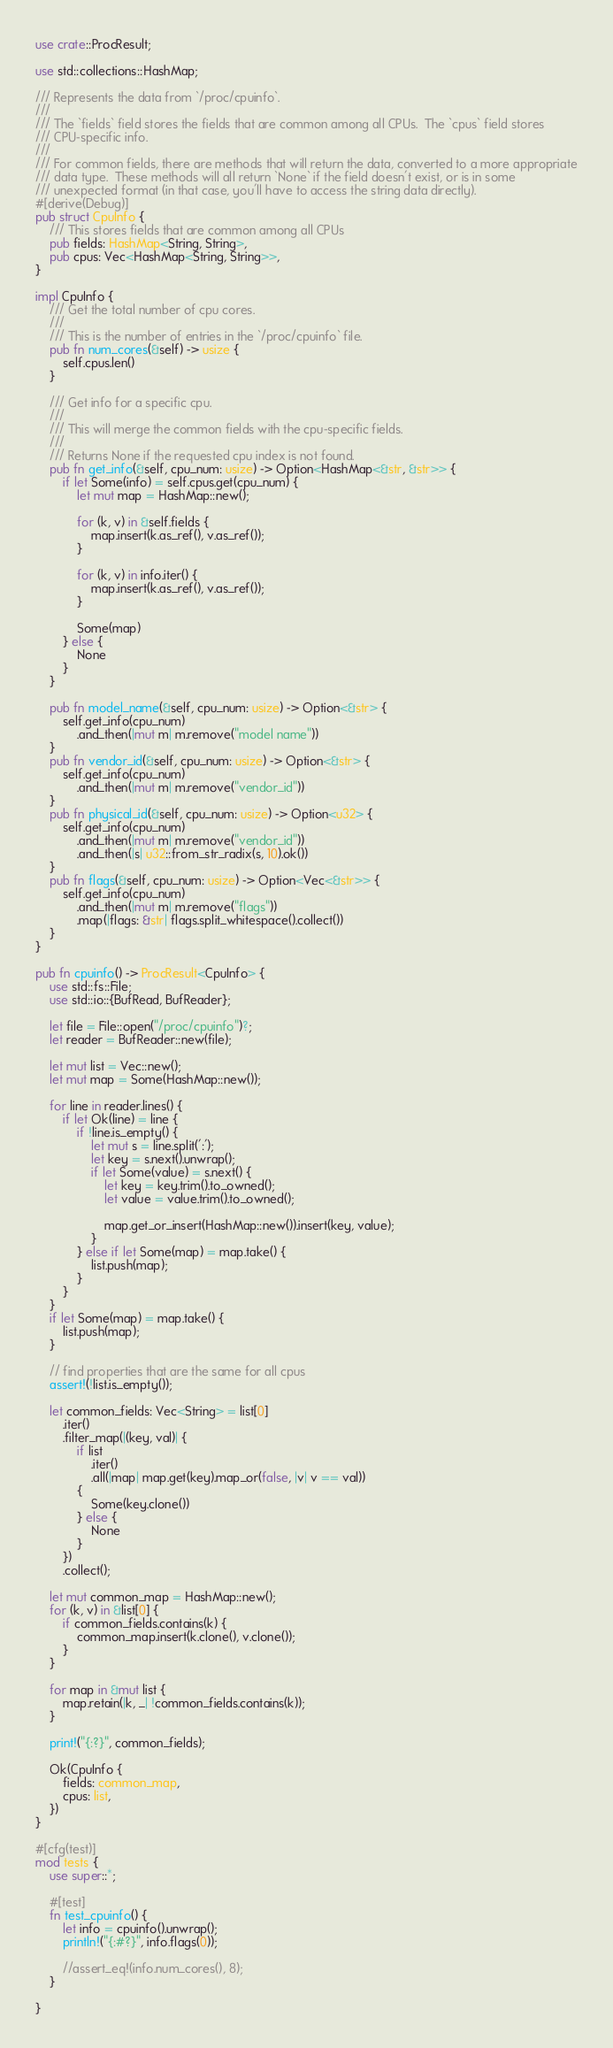Convert code to text. <code><loc_0><loc_0><loc_500><loc_500><_Rust_>use crate::ProcResult;

use std::collections::HashMap;

/// Represents the data from `/proc/cpuinfo`.
///
/// The `fields` field stores the fields that are common among all CPUs.  The `cpus` field stores
/// CPU-specific info.
///
/// For common fields, there are methods that will return the data, converted to a more appropriate
/// data type.  These methods will all return `None` if the field doesn't exist, or is in some
/// unexpected format (in that case, you'll have to access the string data directly).
#[derive(Debug)]
pub struct CpuInfo {
    /// This stores fields that are common among all CPUs
    pub fields: HashMap<String, String>,
    pub cpus: Vec<HashMap<String, String>>,
}

impl CpuInfo {
    /// Get the total number of cpu cores.
    ///
    /// This is the number of entries in the `/proc/cpuinfo` file.
    pub fn num_cores(&self) -> usize {
        self.cpus.len()
    }

    /// Get info for a specific cpu.
    ///
    /// This will merge the common fields with the cpu-specific fields.
    ///
    /// Returns None if the requested cpu index is not found.
    pub fn get_info(&self, cpu_num: usize) -> Option<HashMap<&str, &str>> {
        if let Some(info) = self.cpus.get(cpu_num) {
            let mut map = HashMap::new();

            for (k, v) in &self.fields {
                map.insert(k.as_ref(), v.as_ref());
            }

            for (k, v) in info.iter() {
                map.insert(k.as_ref(), v.as_ref());
            }

            Some(map)
        } else {
            None
        }
    }

    pub fn model_name(&self, cpu_num: usize) -> Option<&str> {
        self.get_info(cpu_num)
            .and_then(|mut m| m.remove("model name"))
    }
    pub fn vendor_id(&self, cpu_num: usize) -> Option<&str> {
        self.get_info(cpu_num)
            .and_then(|mut m| m.remove("vendor_id"))
    }
    pub fn physical_id(&self, cpu_num: usize) -> Option<u32> {
        self.get_info(cpu_num)
            .and_then(|mut m| m.remove("vendor_id"))
            .and_then(|s| u32::from_str_radix(s, 10).ok())
    }
    pub fn flags(&self, cpu_num: usize) -> Option<Vec<&str>> {
        self.get_info(cpu_num)
            .and_then(|mut m| m.remove("flags"))
            .map(|flags: &str| flags.split_whitespace().collect())
    }
}

pub fn cpuinfo() -> ProcResult<CpuInfo> {
    use std::fs::File;
    use std::io::{BufRead, BufReader};

    let file = File::open("/proc/cpuinfo")?;
    let reader = BufReader::new(file);

    let mut list = Vec::new();
    let mut map = Some(HashMap::new());

    for line in reader.lines() {
        if let Ok(line) = line {
            if !line.is_empty() {
                let mut s = line.split(':');
                let key = s.next().unwrap();
                if let Some(value) = s.next() {
                    let key = key.trim().to_owned();
                    let value = value.trim().to_owned();

                    map.get_or_insert(HashMap::new()).insert(key, value);
                }
            } else if let Some(map) = map.take() {
                list.push(map);
            }
        }
    }
    if let Some(map) = map.take() {
        list.push(map);
    }

    // find properties that are the same for all cpus
    assert!(!list.is_empty());

    let common_fields: Vec<String> = list[0]
        .iter()
        .filter_map(|(key, val)| {
            if list
                .iter()
                .all(|map| map.get(key).map_or(false, |v| v == val))
            {
                Some(key.clone())
            } else {
                None
            }
        })
        .collect();

    let mut common_map = HashMap::new();
    for (k, v) in &list[0] {
        if common_fields.contains(k) {
            common_map.insert(k.clone(), v.clone());
        }
    }

    for map in &mut list {
        map.retain(|k, _| !common_fields.contains(k));
    }

    print!("{:?}", common_fields);

    Ok(CpuInfo {
        fields: common_map,
        cpus: list,
    })
}

#[cfg(test)]
mod tests {
    use super::*;

    #[test]
    fn test_cpuinfo() {
        let info = cpuinfo().unwrap();
        println!("{:#?}", info.flags(0));

        //assert_eq!(info.num_cores(), 8);
    }

}
</code> 